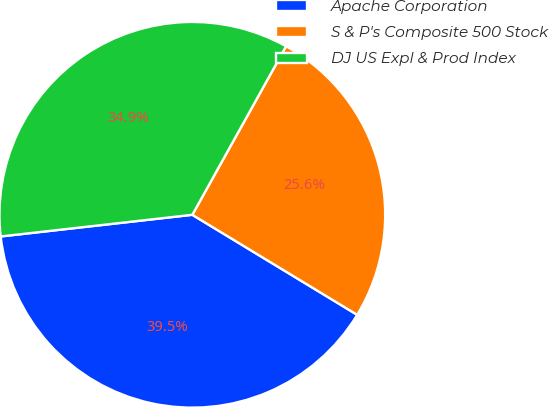<chart> <loc_0><loc_0><loc_500><loc_500><pie_chart><fcel>Apache Corporation<fcel>S & P's Composite 500 Stock<fcel>DJ US Expl & Prod Index<nl><fcel>39.53%<fcel>25.6%<fcel>34.87%<nl></chart> 